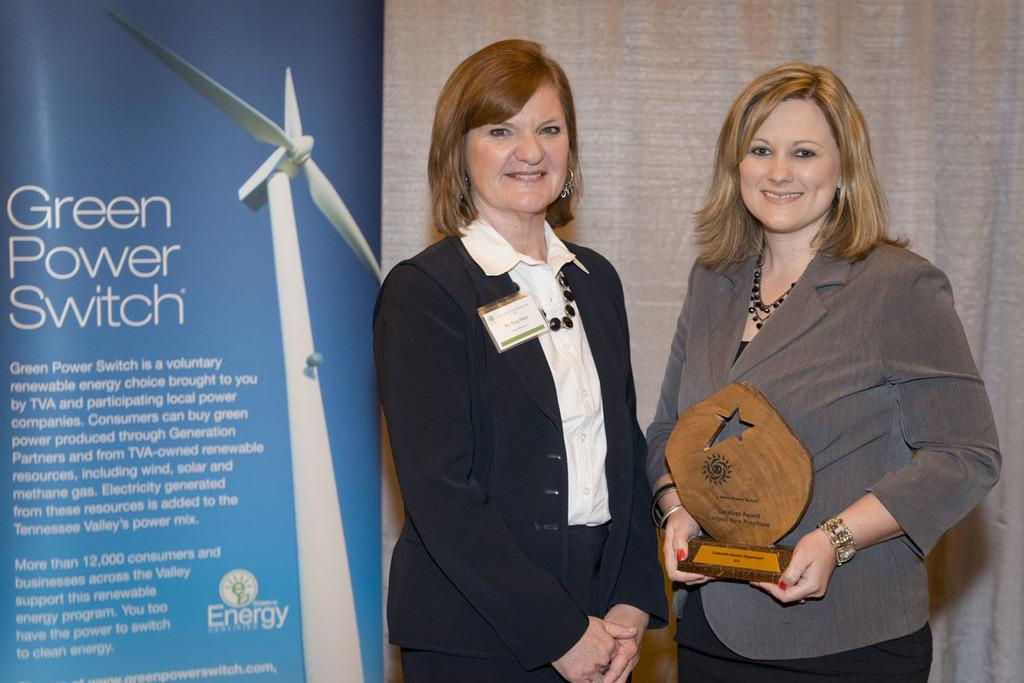How many women are in the image? There are two women in the image. What is one of the women holding? One of the women is holding an award. What is located beside the woman holding the award? There is a banner beside the woman holding the award. What can be seen in the background of the image? There is a curtain in the background of the image. How many crates are visible in the image? There are no crates present in the image. What type of class is being held in the image? There is no indication of a class being held in the image. 